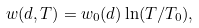Convert formula to latex. <formula><loc_0><loc_0><loc_500><loc_500>w ( d , T ) = w _ { 0 } ( d ) \ln ( T / T _ { 0 } ) ,</formula> 